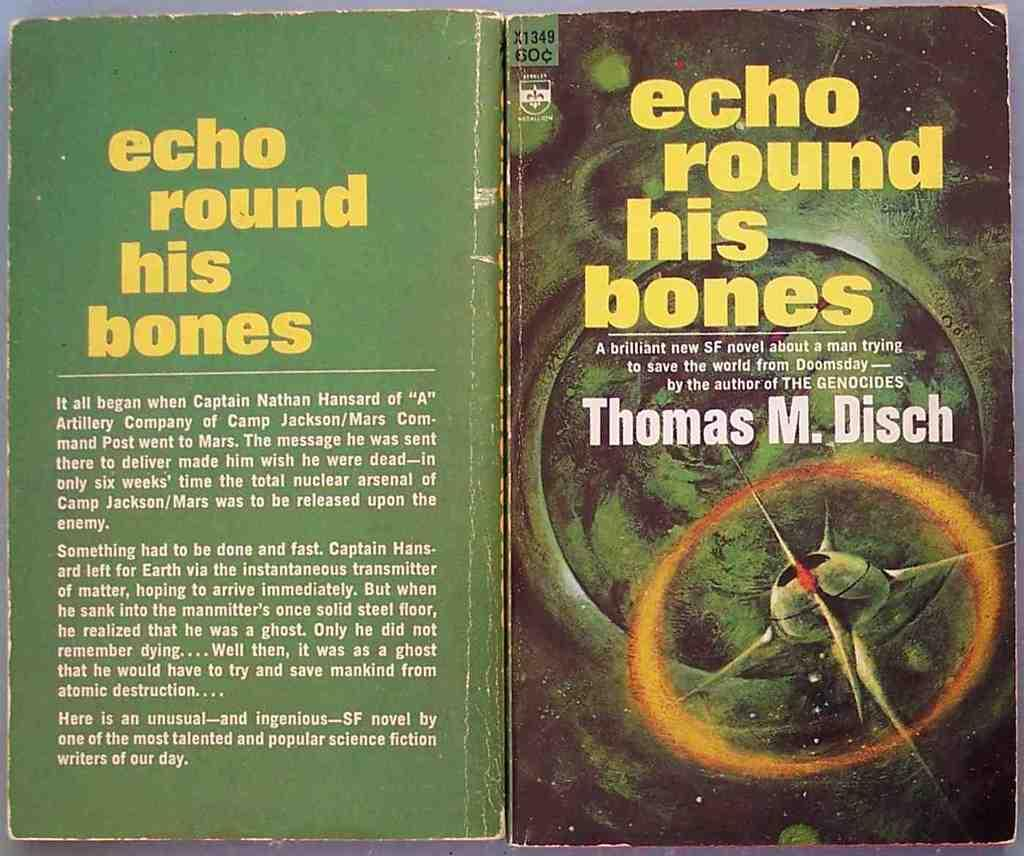<image>
Provide a brief description of the given image. A book by Thomas M. Disch has a green cover. 